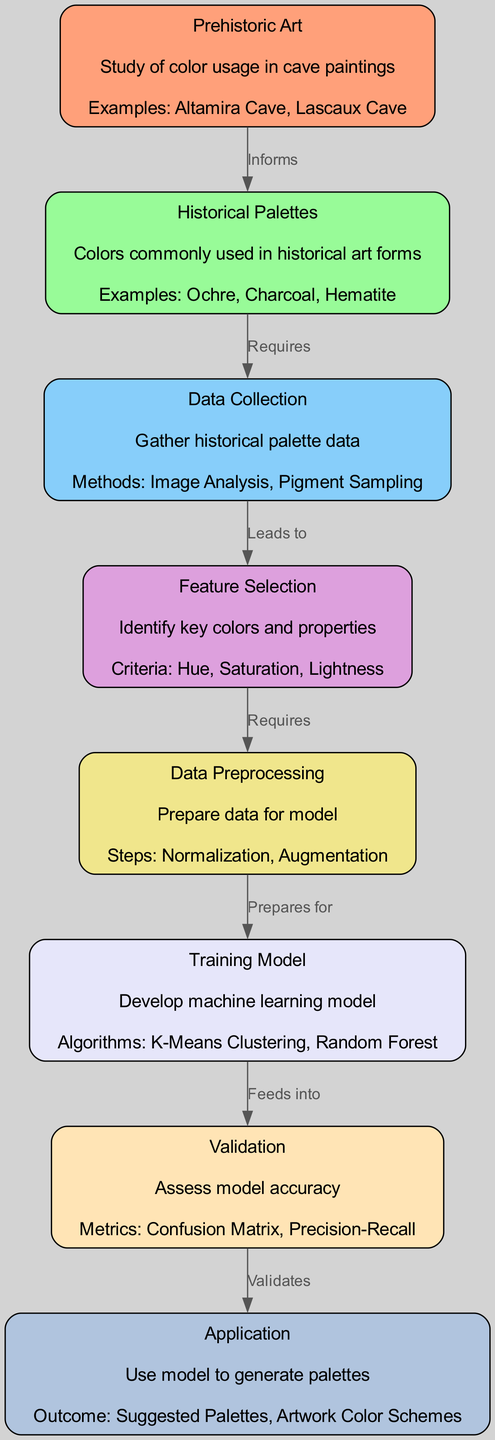What is the main focus of the diagram? The diagram primarily focuses on "Color Palette Recommendations for Modern Artists Based on Historical Preferences." This can be inferred from the title and the interconnected nodes related to prehistoric art and historical palettes.
Answer: Color Palette Recommendations for Modern Artists Based on Historical Preferences How many nodes are present in the diagram? By counting the nodes listed in the data, there are eight unique entities representing different stages of the machine learning process.
Answer: 8 What does "Prehistoric Art" inform? According to the edge labeled "Informs," "Prehistoric Art" informs "Historical Palettes," indicating that the study of prehistoric color usage guides our understanding of historical color choices.
Answer: Historical Palettes Which node requires data collection? The edge labeled "Requires" shows that "Historical Palettes" requires "Data Collection" to gather relevant color data from historical sources.
Answer: Data Collection What does "Training Model" feed into? The edge labeled "Feeds into" indicates that "Training Model" feeds into the "Validation" node, demonstrating the flow from model development to its assessment phase.
Answer: Validation What is the purpose of "Validation"? The attributes of the "Validation" node describe it as an assessment step, focusing on metrics like Confusion Matrix and Precision-Recall to check model accuracy.
Answer: Assess model accuracy What methods are used for data collection? In the "Data Collection" node, methods listed include "Image Analysis" and "Pigment Sampling," providing strategies for gathering historical palette data.
Answer: Image Analysis, Pigment Sampling Which node comes before "Application"? The diagram shows a direct relationship indicated by the edge labeled "Validates," meaning that "Validation" must occur before the "Application" of the model to generate color palettes.
Answer: Validation What criteria are used in the feature selection process? The "Feature Selection" node lists "Hue," "Saturation," and "Lightness" as the key criteria for identifying important colors and their properties for the model.
Answer: Hue, Saturation, Lightness 